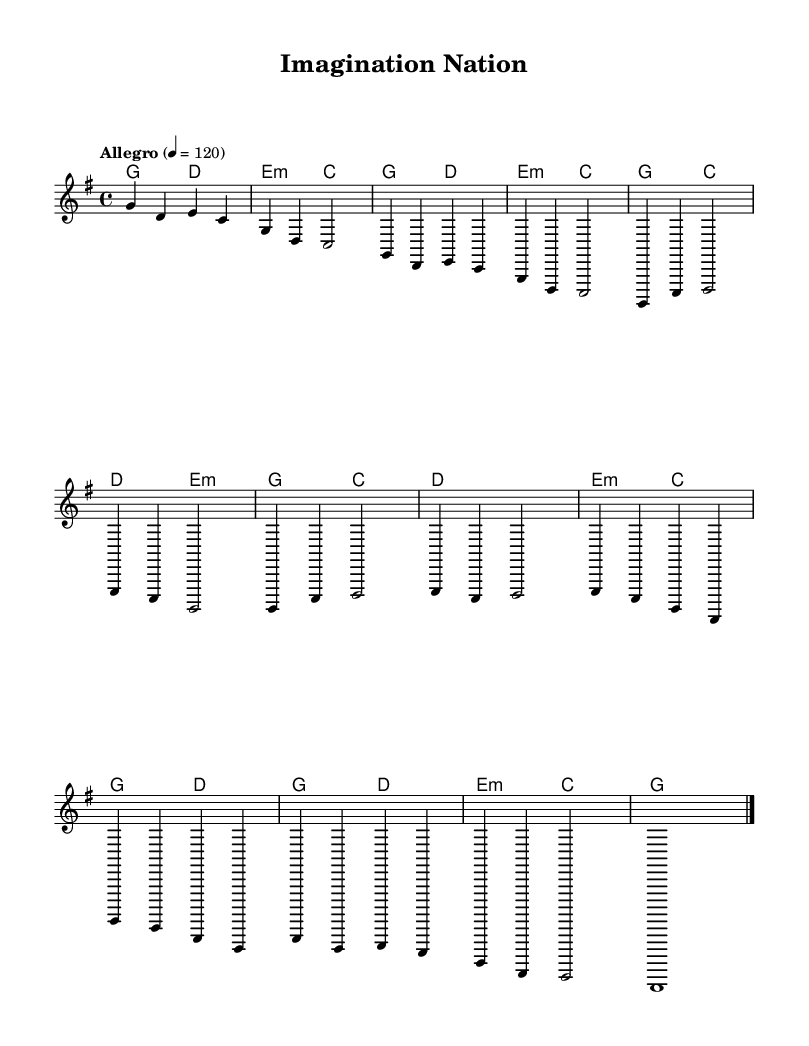What is the key signature of this music? The key signature shows one sharp on the staff, indicating the key of G major.
Answer: G major What is the time signature of this piece? The time signature is displayed as a fraction at the beginning of the staff; it shows that there are four beats in each measure.
Answer: 4/4 What is the tempo marking for the piece? The tempo marking is indicated above the staff and is set to "Allegro", which means a fast tempo, with a metronome marking of 120 beats per minute.
Answer: Allegro, 120 How many measures are in the chorus section? To find the measures in the chorus, one must count the measures listed in the part marked "Chorus"; there are four measures in total.
Answer: 4 What type of chords are primarily used in the verse? By examining the harmony section for the verse, the chords consist of major and minor types; specifically, major and minor chords are alternating.
Answer: Major and minor Does the piece have a bridge section, and if so, how many measures does it contain? The bridge section is visible and counted separately; it contains four measures of music.
Answer: 4 What is the structure of the song based on this sheet music? By analyzing the sections labeled as Intro, Verse 1, Chorus, Bridge, and Outro, one can summarize the structure as: Intro, Verse, Chorus, Bridge, Outro.
Answer: Intro, Verse, Chorus, Bridge, Outro 